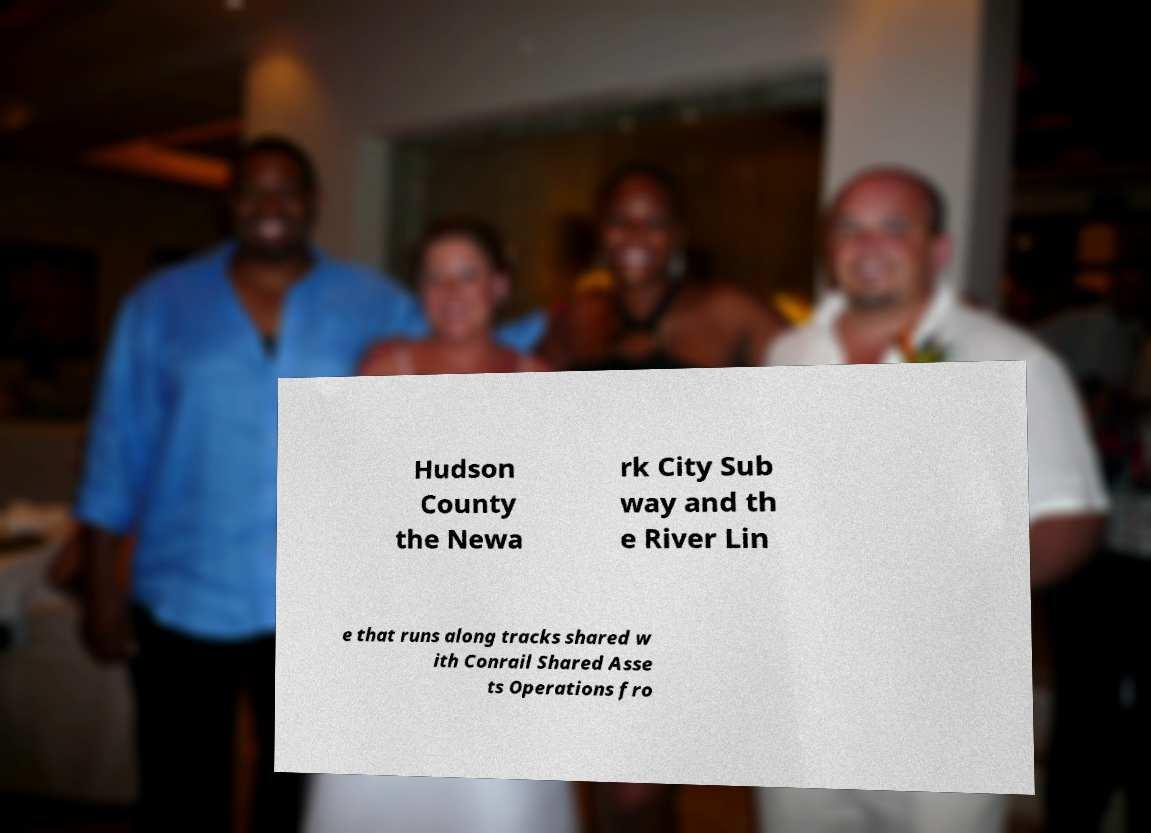I need the written content from this picture converted into text. Can you do that? Hudson County the Newa rk City Sub way and th e River Lin e that runs along tracks shared w ith Conrail Shared Asse ts Operations fro 